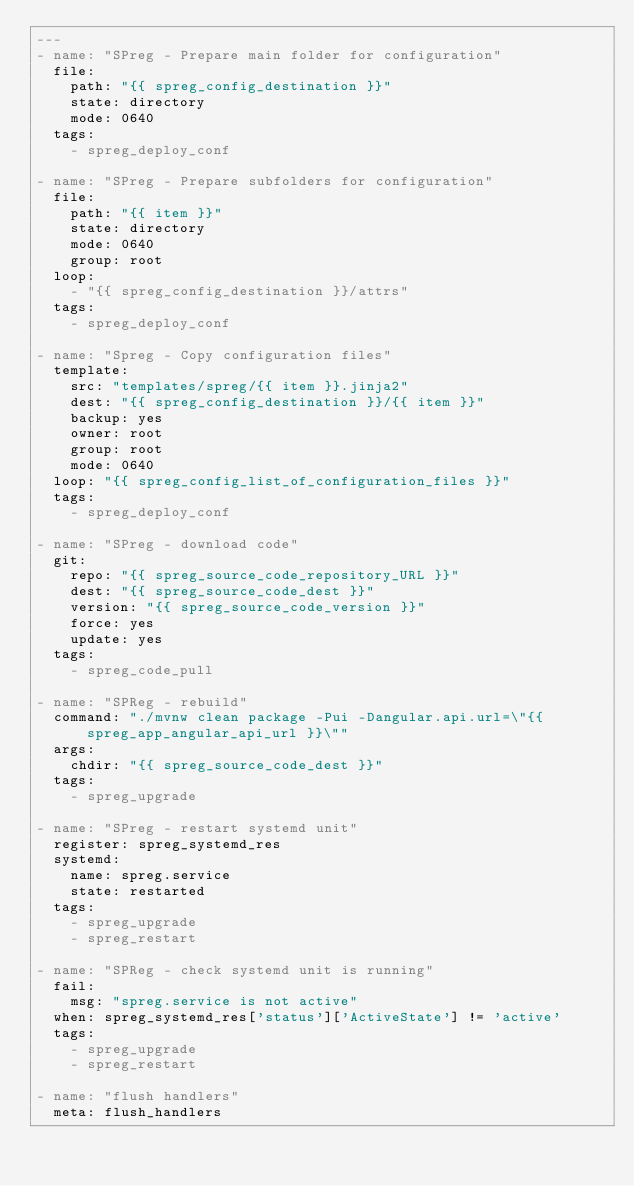Convert code to text. <code><loc_0><loc_0><loc_500><loc_500><_YAML_>---
- name: "SPreg - Prepare main folder for configuration"
  file:
    path: "{{ spreg_config_destination }}"
    state: directory
    mode: 0640
  tags:
    - spreg_deploy_conf

- name: "SPreg - Prepare subfolders for configuration"
  file:
    path: "{{ item }}"
    state: directory
    mode: 0640
    group: root
  loop:
    - "{{ spreg_config_destination }}/attrs"
  tags:
    - spreg_deploy_conf

- name: "Spreg - Copy configuration files"
  template:
    src: "templates/spreg/{{ item }}.jinja2"
    dest: "{{ spreg_config_destination }}/{{ item }}"
    backup: yes
    owner: root
    group: root
    mode: 0640
  loop: "{{ spreg_config_list_of_configuration_files }}"
  tags:
    - spreg_deploy_conf

- name: "SPreg - download code"
  git:
    repo: "{{ spreg_source_code_repository_URL }}"
    dest: "{{ spreg_source_code_dest }}"
    version: "{{ spreg_source_code_version }}"
    force: yes
    update: yes
  tags:
    - spreg_code_pull

- name: "SPReg - rebuild"
  command: "./mvnw clean package -Pui -Dangular.api.url=\"{{ spreg_app_angular_api_url }}\""
  args:
    chdir: "{{ spreg_source_code_dest }}"
  tags:
    - spreg_upgrade

- name: "SPreg - restart systemd unit"
  register: spreg_systemd_res
  systemd:
    name: spreg.service
    state: restarted
  tags:
    - spreg_upgrade
    - spreg_restart

- name: "SPReg - check systemd unit is running"
  fail:
    msg: "spreg.service is not active"
  when: spreg_systemd_res['status']['ActiveState'] != 'active'
  tags:
    - spreg_upgrade
    - spreg_restart

- name: "flush handlers"
  meta: flush_handlers
</code> 